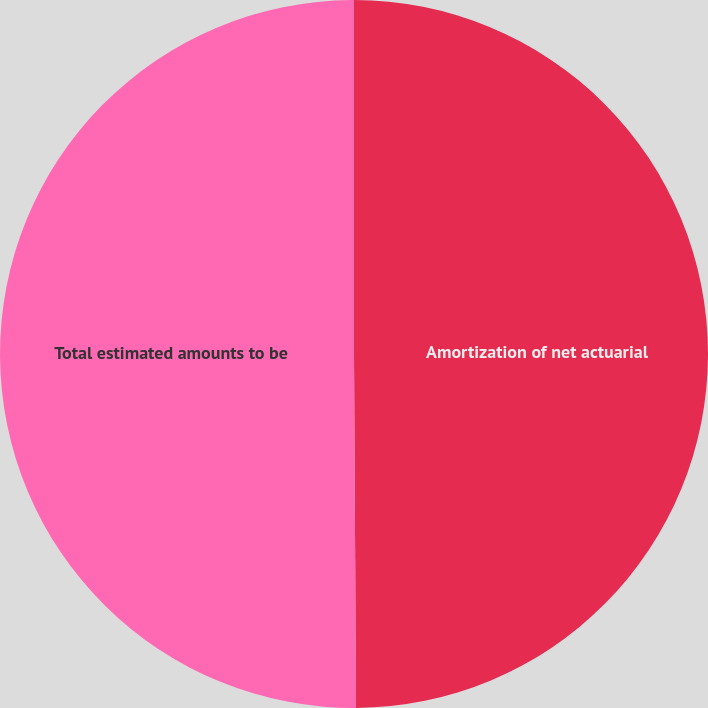Convert chart. <chart><loc_0><loc_0><loc_500><loc_500><pie_chart><fcel>Amortization of net actuarial<fcel>Total estimated amounts to be<nl><fcel>49.91%<fcel>50.09%<nl></chart> 